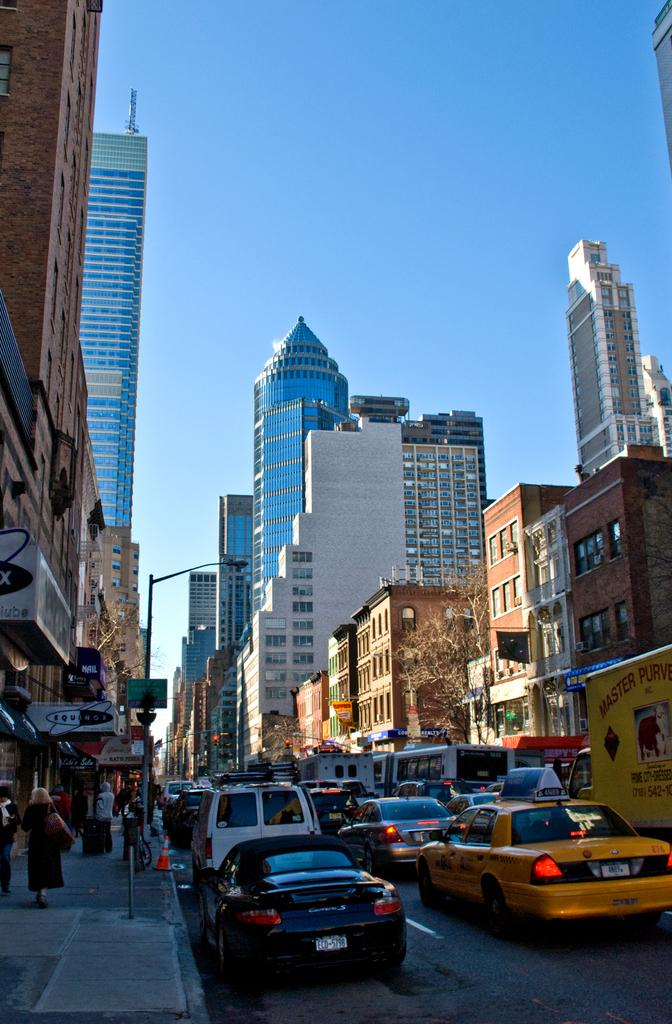<image>
Offer a succinct explanation of the picture presented. One of the many cars on this street is a Porsche with the license plate number ECD-5798. 